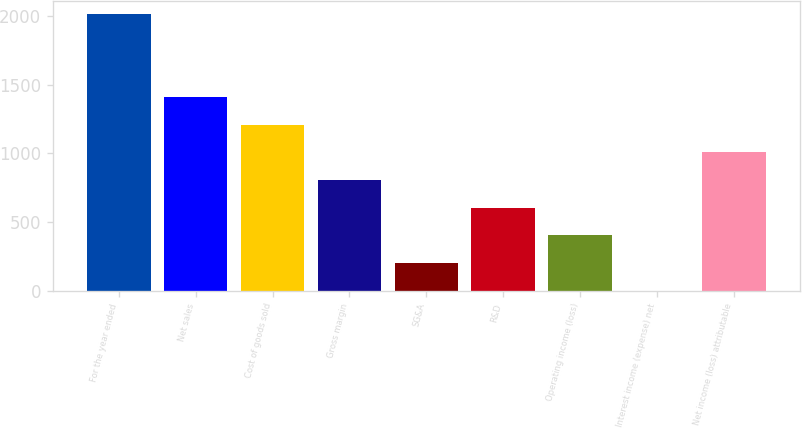Convert chart to OTSL. <chart><loc_0><loc_0><loc_500><loc_500><bar_chart><fcel>For the year ended<fcel>Net sales<fcel>Cost of goods sold<fcel>Gross margin<fcel>SG&A<fcel>R&D<fcel>Operating income (loss)<fcel>Interest income (expense) net<fcel>Net income (loss) attributable<nl><fcel>2012<fcel>1409<fcel>1208<fcel>806<fcel>203<fcel>605<fcel>404<fcel>2<fcel>1007<nl></chart> 